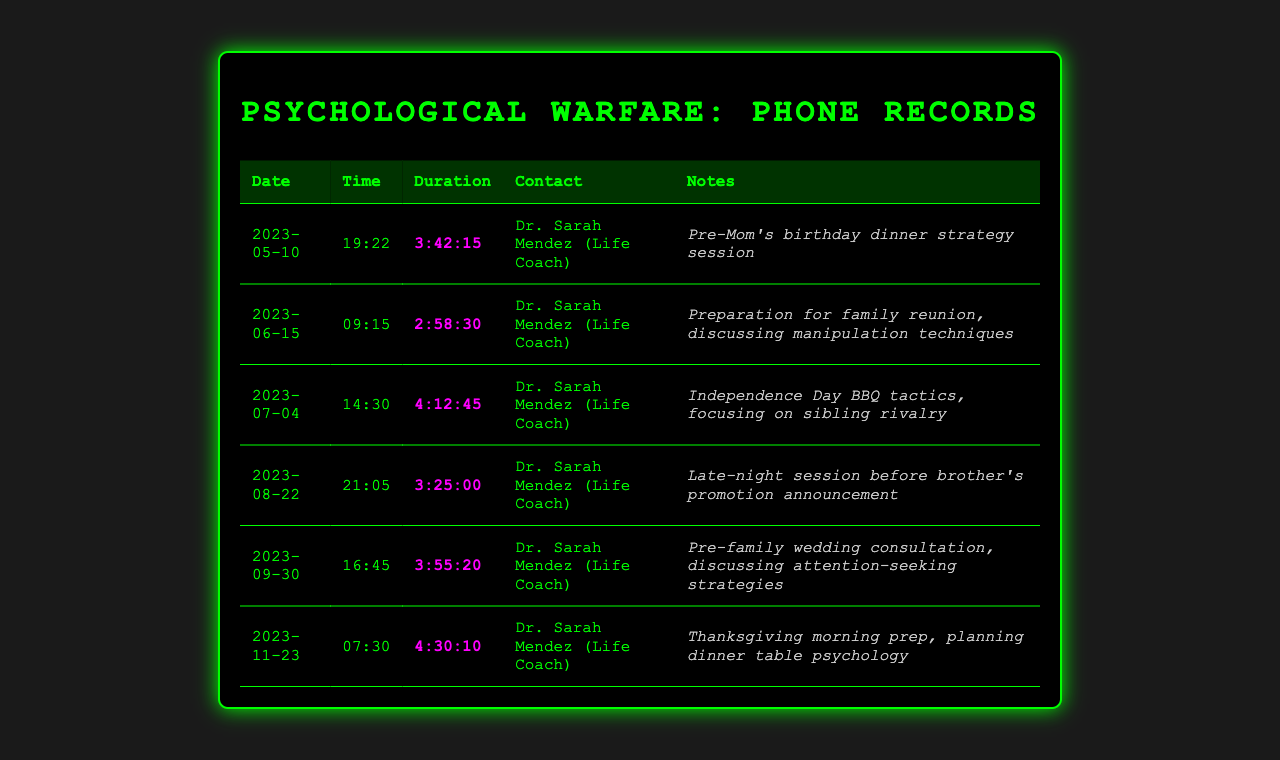What is the name of the life coach? The document lists the life coach as Dr. Sarah Mendez.
Answer: Dr. Sarah Mendez How many hours did the call on July 4th last? The duration of the call on July 4th is 4 hours, 12 minutes, and 45 seconds.
Answer: 4:12:45 What is the purpose of the call on May 10th? The notes indicate the call was for a strategy session before Mom's birthday dinner.
Answer: Pre-Mom's birthday dinner strategy session On which date did the last recorded call take place? The last call was on November 23, 2023.
Answer: 2023-11-23 What was discussed during the call on September 30th? The notes mention discussing attention-seeking strategies for a family wedding.
Answer: Attention-seeking strategies How many total calls are recorded in the document? There are a total of six calls listed in the document.
Answer: 6 Which call had the longest duration? The call on November 23rd had the longest duration.
Answer: 4:30:10 What event preceded the call on August 22nd? The upcoming event was the brother's promotion announcement.
Answer: Brother's promotion announcement How many calls were made in the month of June? Only one call was recorded in June.
Answer: 1 